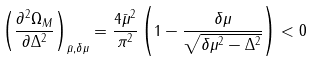Convert formula to latex. <formula><loc_0><loc_0><loc_500><loc_500>\left ( \frac { \partial ^ { 2 } \Omega _ { M } } { \partial \Delta ^ { 2 } } \right ) _ { \bar { \mu } , \delta \mu } = \frac { 4 \bar { \mu } ^ { 2 } } { \pi ^ { 2 } } \left ( 1 - \frac { \delta \mu } { \sqrt { \delta \mu ^ { 2 } - \Delta ^ { 2 } } } \right ) < 0</formula> 